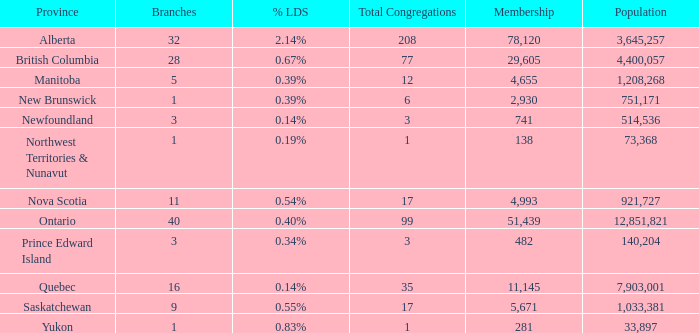What's the sum of population when the membership is 51,439 for fewer than 40 branches? None. 